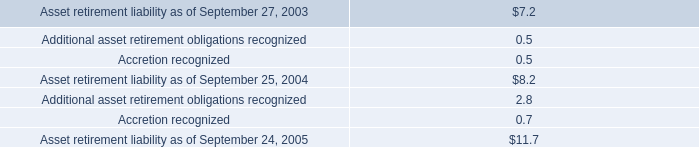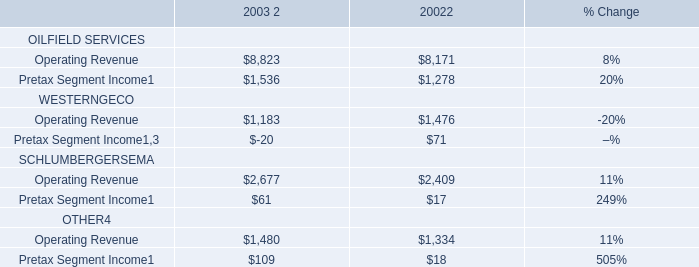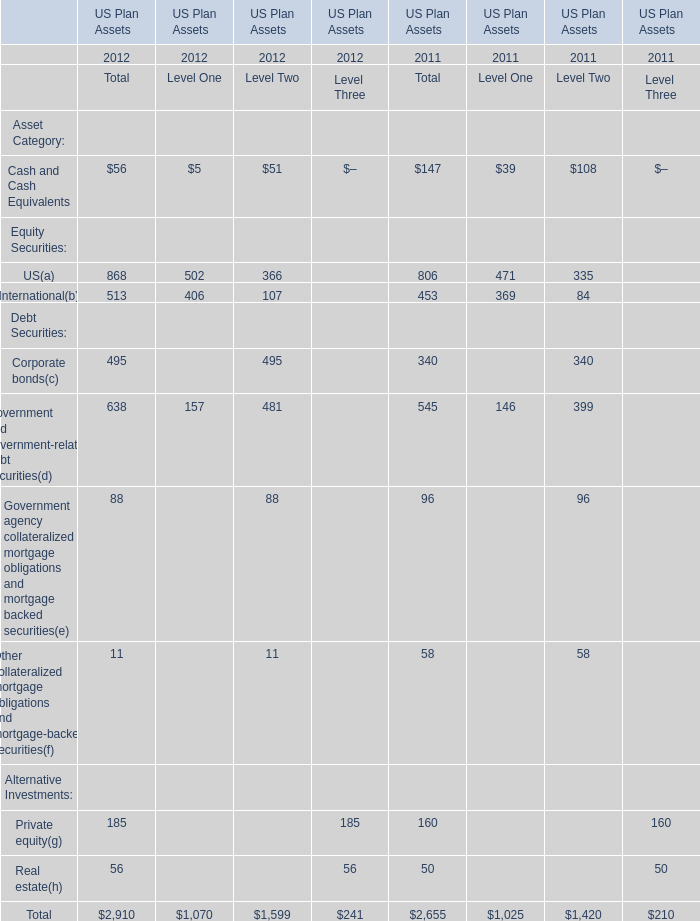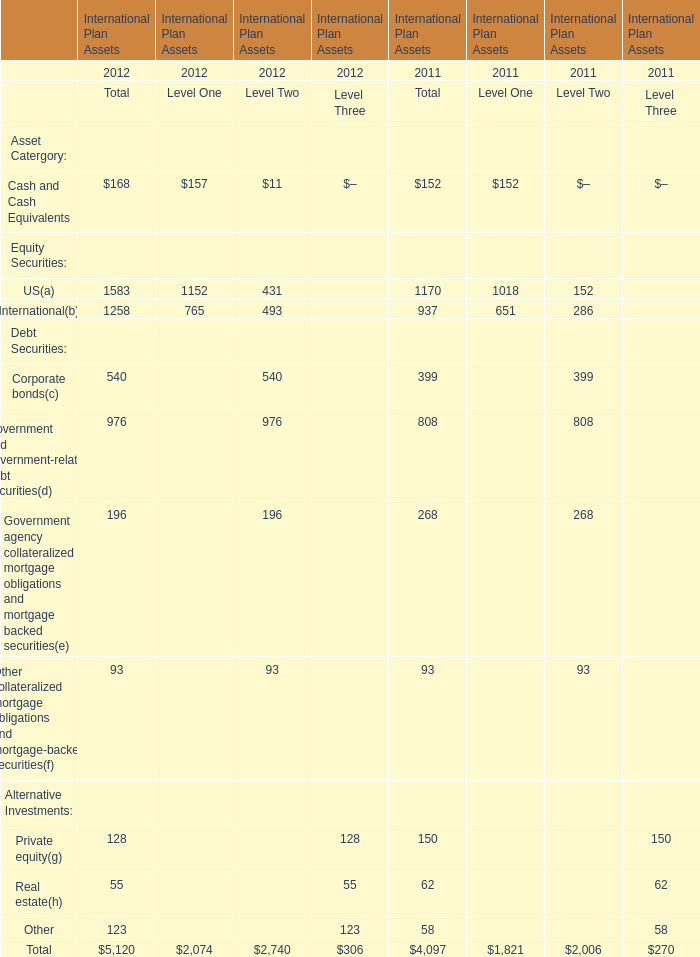What was the average of the Government and government-related debt securities(d)in the years where Cash and Cash Equivalents is positive? 
Computations: ((976 + 808) / 2)
Answer: 892.0. 